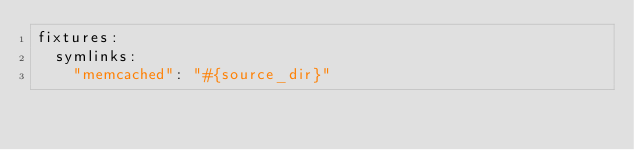Convert code to text. <code><loc_0><loc_0><loc_500><loc_500><_YAML_>fixtures:
  symlinks:
    "memcached": "#{source_dir}"
</code> 